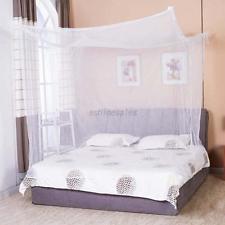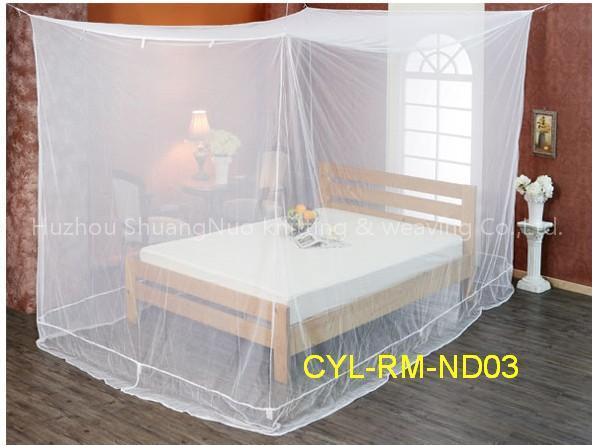The first image is the image on the left, the second image is the image on the right. Examine the images to the left and right. Is the description "One image shows a canopy suspended from the ceiling that drapes the bed from a cone shape." accurate? Answer yes or no. No. 